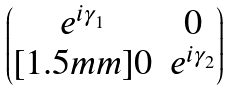<formula> <loc_0><loc_0><loc_500><loc_500>\begin{pmatrix} e ^ { i \gamma _ { 1 } } & 0 \\ [ 1 . 5 m m ] 0 & e ^ { i \gamma _ { 2 } } \end{pmatrix}</formula> 